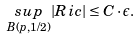Convert formula to latex. <formula><loc_0><loc_0><loc_500><loc_500>\underset { B ( p , 1 / 2 ) } { s u p } | R i c | \leq C \cdot \epsilon .</formula> 